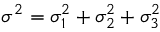<formula> <loc_0><loc_0><loc_500><loc_500>\sigma ^ { 2 } = \sigma _ { 1 } ^ { 2 } + \sigma _ { 2 } ^ { 2 } + \sigma _ { 3 } ^ { 2 }</formula> 